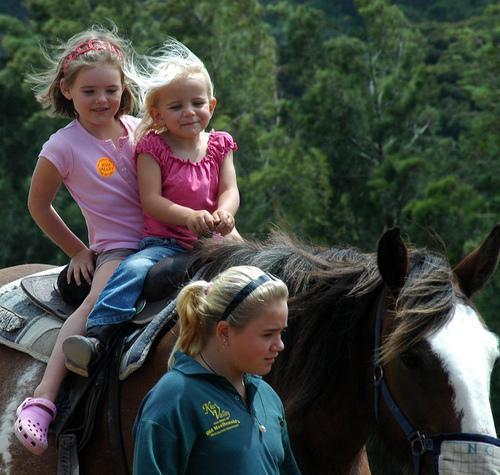What color is the person who is responsible for the safety of the two girls on horseback wearing?
Make your selection and explain in format: 'Answer: answer
Rationale: rationale.'
Options: Teal, black, pink, blue. Answer: teal.
Rationale: An older adult is walking beside a horse as two young girls ride the horse. 